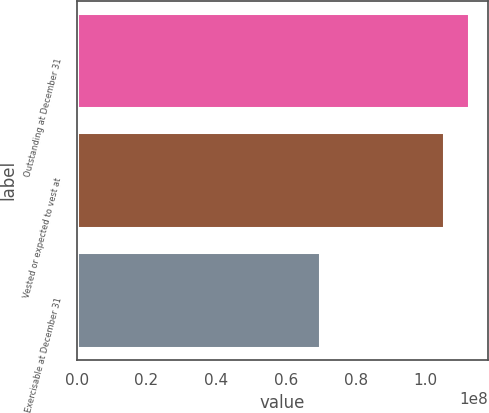Convert chart to OTSL. <chart><loc_0><loc_0><loc_500><loc_500><bar_chart><fcel>Outstanding at December 31<fcel>Vested or expected to vest at<fcel>Exercisable at December 31<nl><fcel>1.12311e+08<fcel>1.05414e+08<fcel>6.98557e+07<nl></chart> 